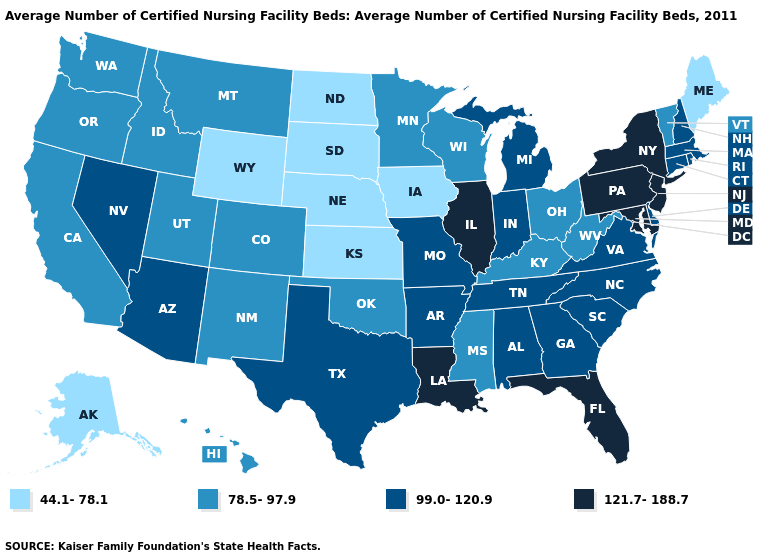What is the value of Maine?
Short answer required. 44.1-78.1. Among the states that border North Carolina , which have the highest value?
Short answer required. Georgia, South Carolina, Tennessee, Virginia. What is the value of California?
Short answer required. 78.5-97.9. What is the highest value in the MidWest ?
Short answer required. 121.7-188.7. Name the states that have a value in the range 78.5-97.9?
Write a very short answer. California, Colorado, Hawaii, Idaho, Kentucky, Minnesota, Mississippi, Montana, New Mexico, Ohio, Oklahoma, Oregon, Utah, Vermont, Washington, West Virginia, Wisconsin. What is the highest value in states that border Wisconsin?
Short answer required. 121.7-188.7. Which states have the lowest value in the USA?
Be succinct. Alaska, Iowa, Kansas, Maine, Nebraska, North Dakota, South Dakota, Wyoming. What is the lowest value in the MidWest?
Write a very short answer. 44.1-78.1. Which states hav the highest value in the South?
Write a very short answer. Florida, Louisiana, Maryland. Name the states that have a value in the range 121.7-188.7?
Quick response, please. Florida, Illinois, Louisiana, Maryland, New Jersey, New York, Pennsylvania. What is the lowest value in the USA?
Keep it brief. 44.1-78.1. Does New Hampshire have the lowest value in the Northeast?
Concise answer only. No. Which states have the lowest value in the West?
Concise answer only. Alaska, Wyoming. Name the states that have a value in the range 44.1-78.1?
Quick response, please. Alaska, Iowa, Kansas, Maine, Nebraska, North Dakota, South Dakota, Wyoming. What is the value of Mississippi?
Short answer required. 78.5-97.9. 